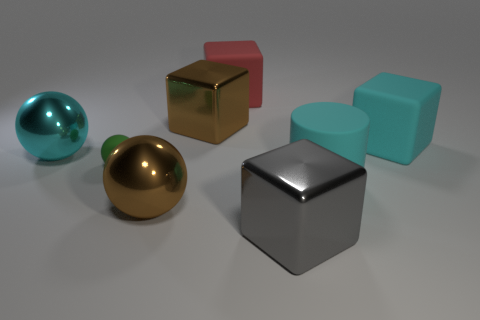Is there anything else that has the same size as the green rubber ball?
Offer a terse response. No. How many small green balls are behind the cyan metallic object?
Provide a succinct answer. 0. Are there any tiny green things that have the same material as the green ball?
Give a very brief answer. No. What is the shape of the large shiny thing that is the same color as the cylinder?
Your answer should be compact. Sphere. What color is the large shiny cube on the left side of the large gray object?
Keep it short and to the point. Brown. Are there an equal number of brown balls in front of the large cyan shiny thing and matte cylinders that are on the left side of the small green rubber sphere?
Make the answer very short. No. There is a big cyan object that is left of the large cube in front of the big cyan sphere; what is it made of?
Offer a very short reply. Metal. What number of things are big objects or large objects behind the large brown metallic ball?
Your response must be concise. 7. The green thing that is made of the same material as the big cylinder is what size?
Make the answer very short. Small. Is the number of shiny cubes behind the green rubber object greater than the number of tiny blue shiny blocks?
Keep it short and to the point. Yes. 